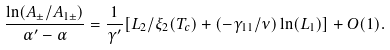<formula> <loc_0><loc_0><loc_500><loc_500>\frac { \ln ( A _ { \pm } / A _ { 1 \pm } ) } { \alpha ^ { \prime } - \alpha } = \frac { 1 } { \gamma ^ { \prime } } [ L _ { 2 } / \xi _ { 2 } ( T _ { c } ) + ( - \gamma _ { 1 1 } / \nu ) \ln ( L _ { 1 } ) ] + O ( 1 ) .</formula> 